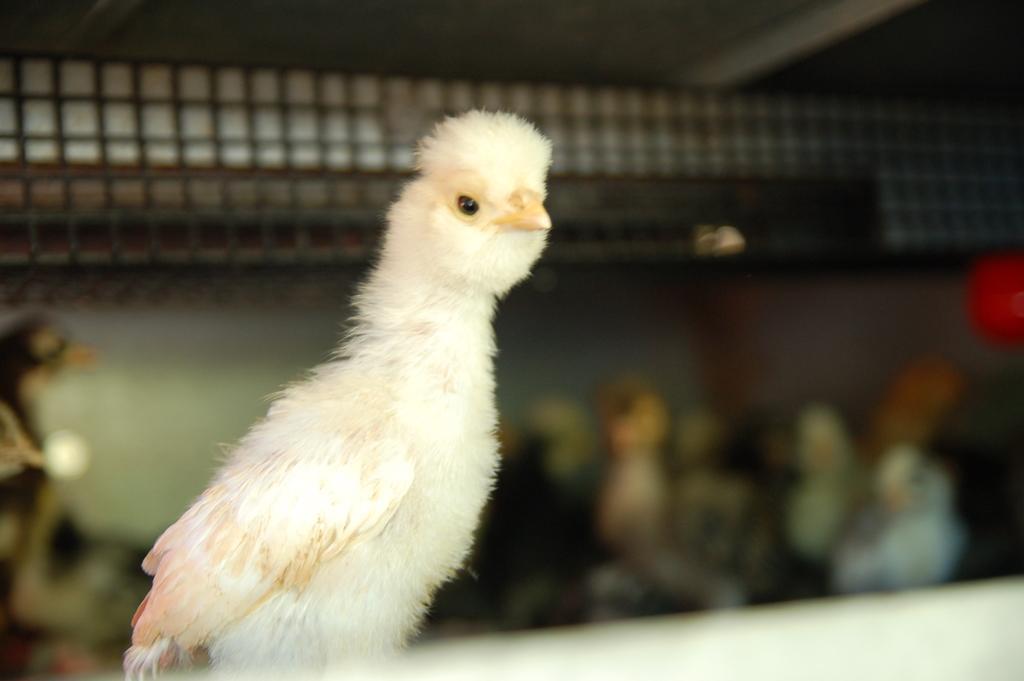Please provide a concise description of this image. In this picture we can see a bird. In the background of the image it is blurry and we can see objects. 